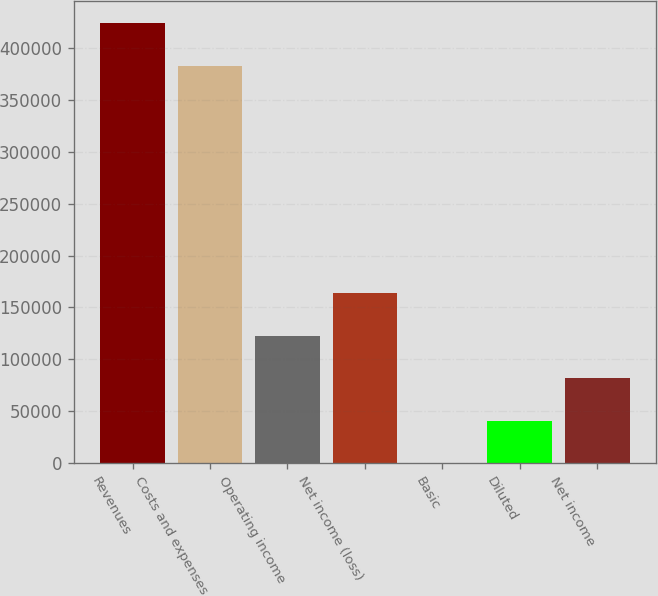Convert chart to OTSL. <chart><loc_0><loc_0><loc_500><loc_500><bar_chart><fcel>Revenues<fcel>Costs and expenses<fcel>Operating income<fcel>Net income (loss)<fcel>Basic<fcel>Diluted<fcel>Net income<nl><fcel>424194<fcel>383330<fcel>122592<fcel>163456<fcel>0.13<fcel>40864<fcel>81727.9<nl></chart> 